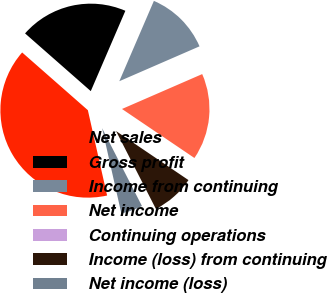Convert chart to OTSL. <chart><loc_0><loc_0><loc_500><loc_500><pie_chart><fcel>Net sales<fcel>Gross profit<fcel>Income from continuing<fcel>Net income<fcel>Continuing operations<fcel>Income (loss) from continuing<fcel>Net income (loss)<nl><fcel>40.0%<fcel>20.0%<fcel>12.0%<fcel>16.0%<fcel>0.0%<fcel>8.0%<fcel>4.0%<nl></chart> 